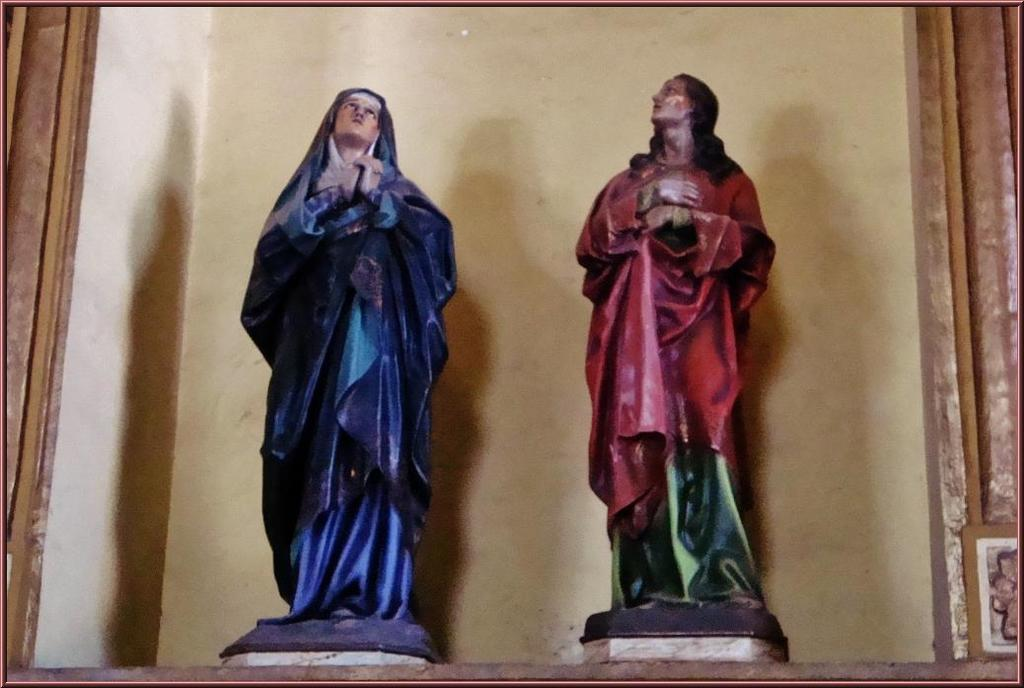Where was the image taken? The image was taken indoors. What can be seen in the background of the image? There is a wall in the background of the image. What are the main subjects in the middle of the image? There are two statues in the middle of the image. What type of sock is the writer wearing in the image? There is no writer or sock present in the image; it features two statues. What type of kettle is visible in the image? There is no kettle present in the image. 